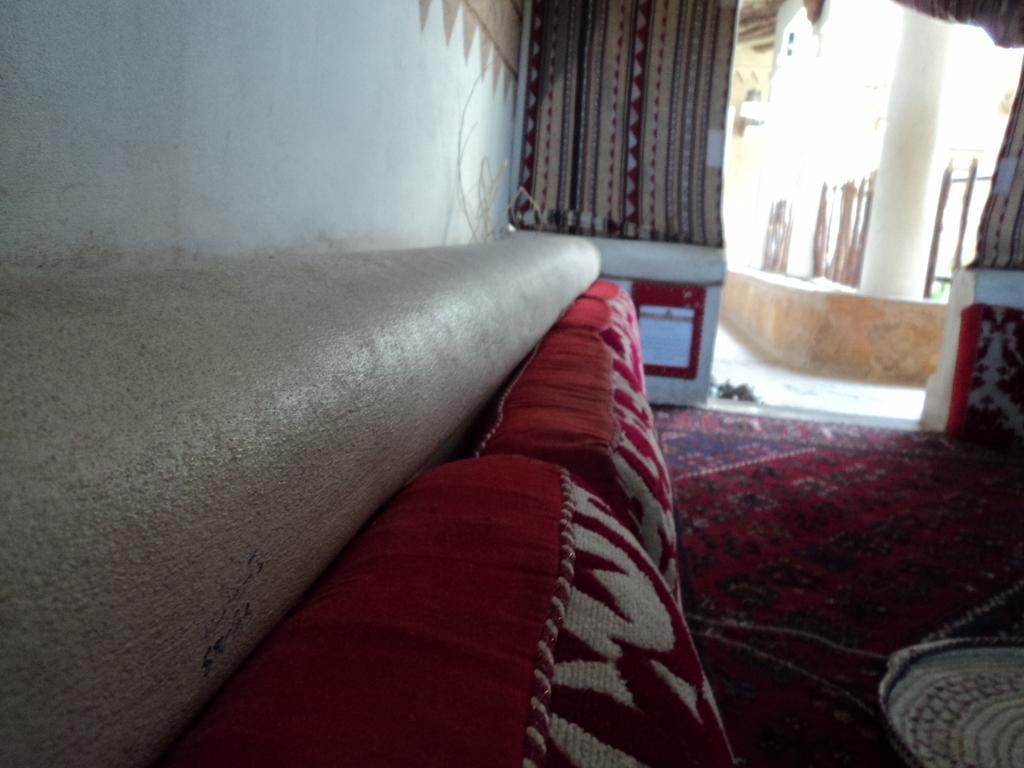Describe this image in one or two sentences. This is an inside view. On the left side, there is a wall. Beside the wall there are few red color pillows. On the right side, I can see a red color mat on the floor. In the Background there is a wall and I can see few curtains. 